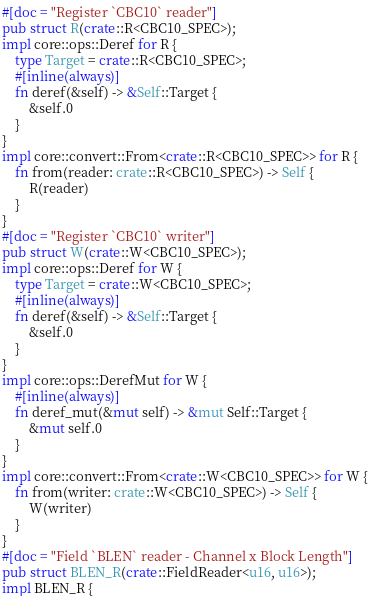Convert code to text. <code><loc_0><loc_0><loc_500><loc_500><_Rust_>#[doc = "Register `CBC10` reader"]
pub struct R(crate::R<CBC10_SPEC>);
impl core::ops::Deref for R {
    type Target = crate::R<CBC10_SPEC>;
    #[inline(always)]
    fn deref(&self) -> &Self::Target {
        &self.0
    }
}
impl core::convert::From<crate::R<CBC10_SPEC>> for R {
    fn from(reader: crate::R<CBC10_SPEC>) -> Self {
        R(reader)
    }
}
#[doc = "Register `CBC10` writer"]
pub struct W(crate::W<CBC10_SPEC>);
impl core::ops::Deref for W {
    type Target = crate::W<CBC10_SPEC>;
    #[inline(always)]
    fn deref(&self) -> &Self::Target {
        &self.0
    }
}
impl core::ops::DerefMut for W {
    #[inline(always)]
    fn deref_mut(&mut self) -> &mut Self::Target {
        &mut self.0
    }
}
impl core::convert::From<crate::W<CBC10_SPEC>> for W {
    fn from(writer: crate::W<CBC10_SPEC>) -> Self {
        W(writer)
    }
}
#[doc = "Field `BLEN` reader - Channel x Block Length"]
pub struct BLEN_R(crate::FieldReader<u16, u16>);
impl BLEN_R {</code> 